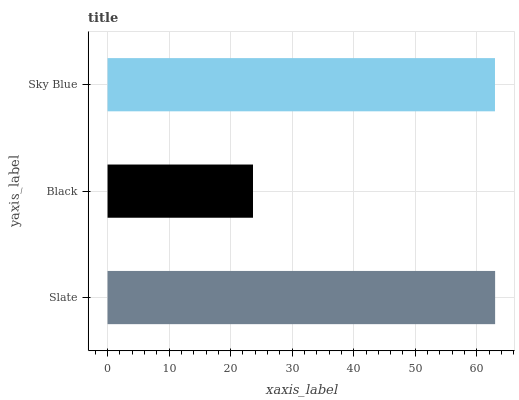Is Black the minimum?
Answer yes or no. Yes. Is Slate the maximum?
Answer yes or no. Yes. Is Sky Blue the minimum?
Answer yes or no. No. Is Sky Blue the maximum?
Answer yes or no. No. Is Sky Blue greater than Black?
Answer yes or no. Yes. Is Black less than Sky Blue?
Answer yes or no. Yes. Is Black greater than Sky Blue?
Answer yes or no. No. Is Sky Blue less than Black?
Answer yes or no. No. Is Sky Blue the high median?
Answer yes or no. Yes. Is Sky Blue the low median?
Answer yes or no. Yes. Is Slate the high median?
Answer yes or no. No. Is Slate the low median?
Answer yes or no. No. 